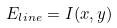<formula> <loc_0><loc_0><loc_500><loc_500>E _ { l i n e } = I ( x , y )</formula> 